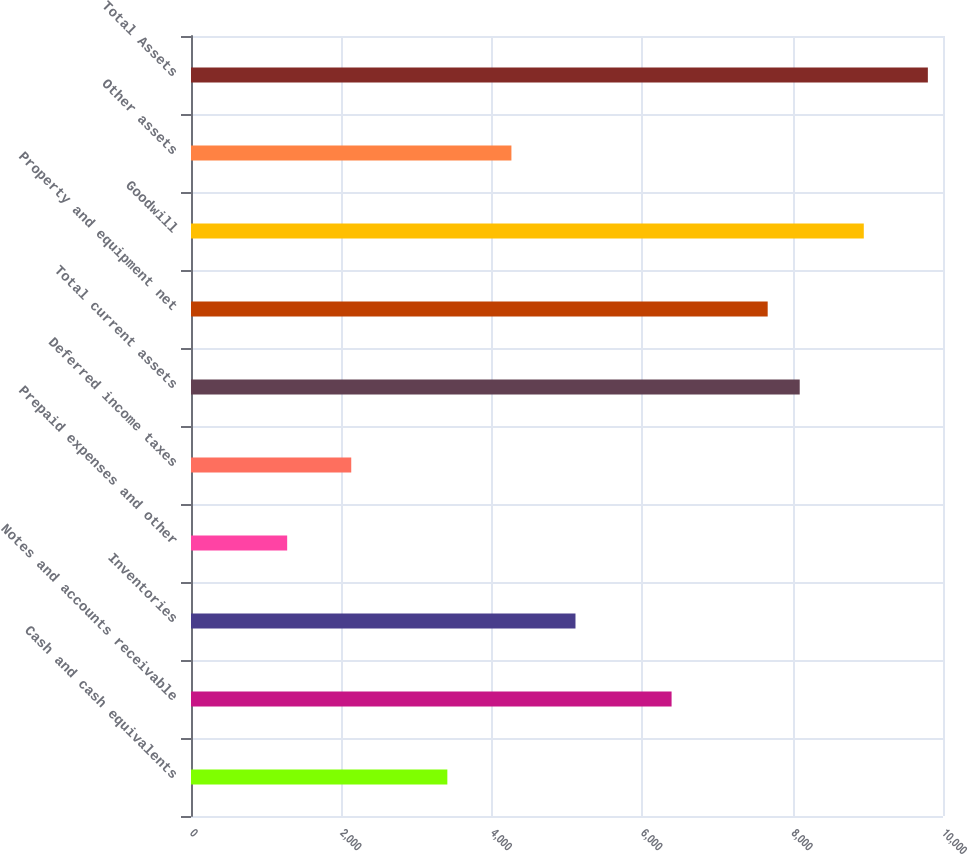Convert chart. <chart><loc_0><loc_0><loc_500><loc_500><bar_chart><fcel>Cash and cash equivalents<fcel>Notes and accounts receivable<fcel>Inventories<fcel>Prepaid expenses and other<fcel>Deferred income taxes<fcel>Total current assets<fcel>Property and equipment net<fcel>Goodwill<fcel>Other assets<fcel>Total Assets<nl><fcel>3408.82<fcel>6390.75<fcel>5112.78<fcel>1278.87<fcel>2130.85<fcel>8094.71<fcel>7668.72<fcel>8946.69<fcel>4260.8<fcel>9798.67<nl></chart> 